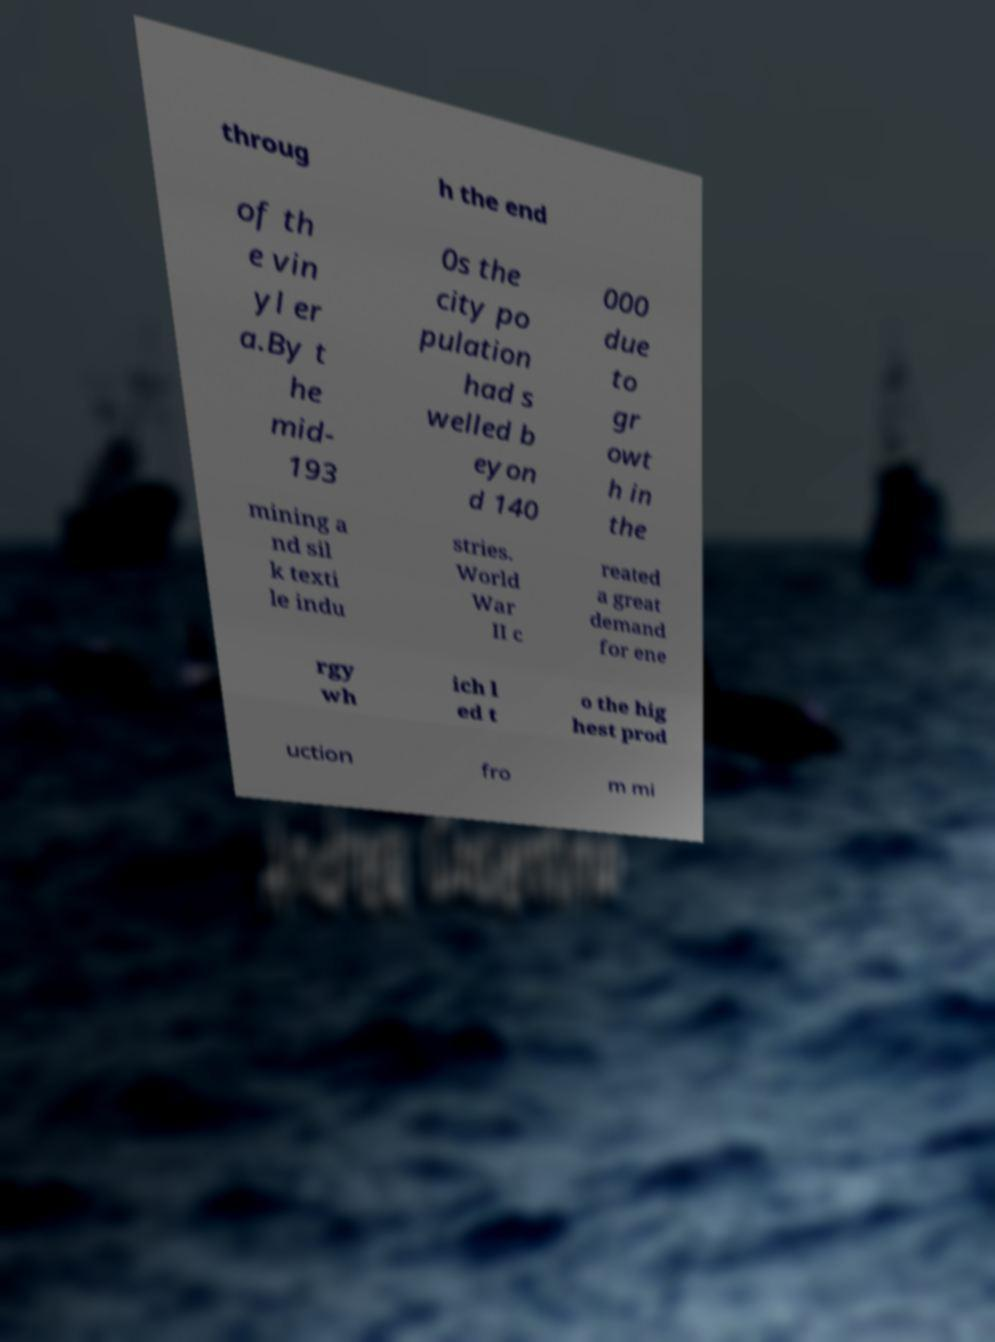Could you assist in decoding the text presented in this image and type it out clearly? throug h the end of th e vin yl er a.By t he mid- 193 0s the city po pulation had s welled b eyon d 140 000 due to gr owt h in the mining a nd sil k texti le indu stries. World War II c reated a great demand for ene rgy wh ich l ed t o the hig hest prod uction fro m mi 